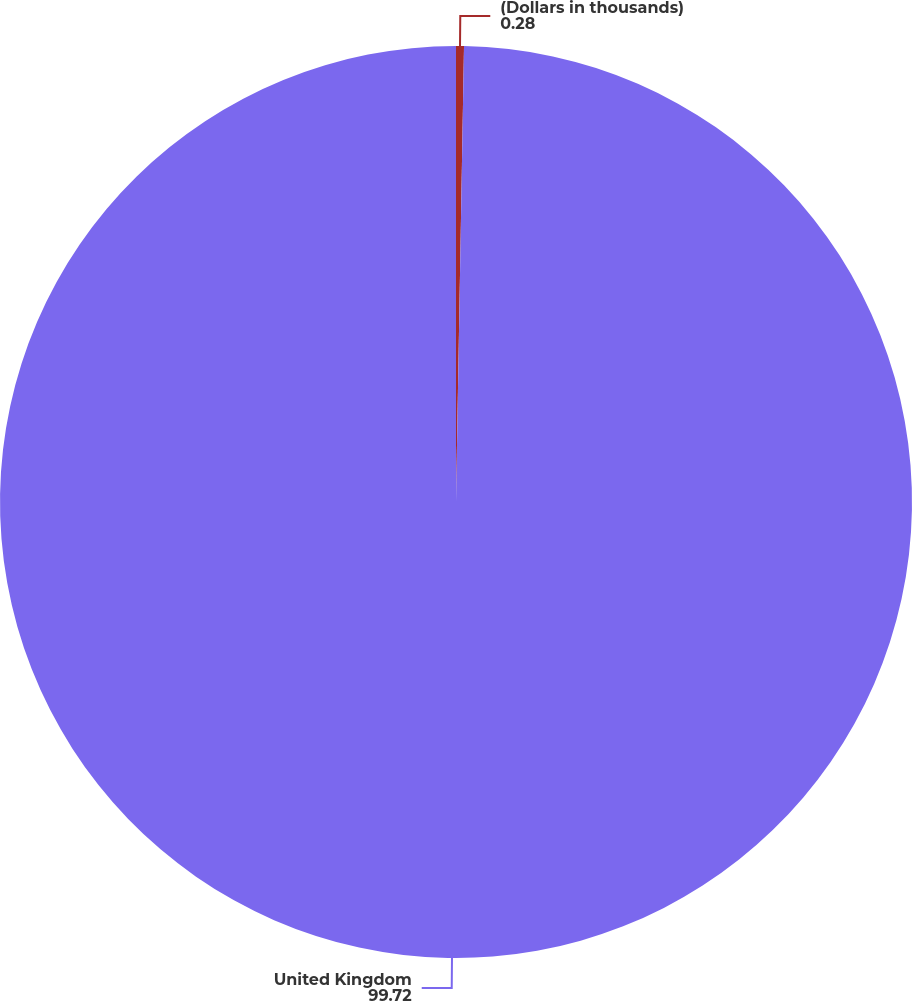<chart> <loc_0><loc_0><loc_500><loc_500><pie_chart><fcel>(Dollars in thousands)<fcel>United Kingdom<nl><fcel>0.28%<fcel>99.72%<nl></chart> 